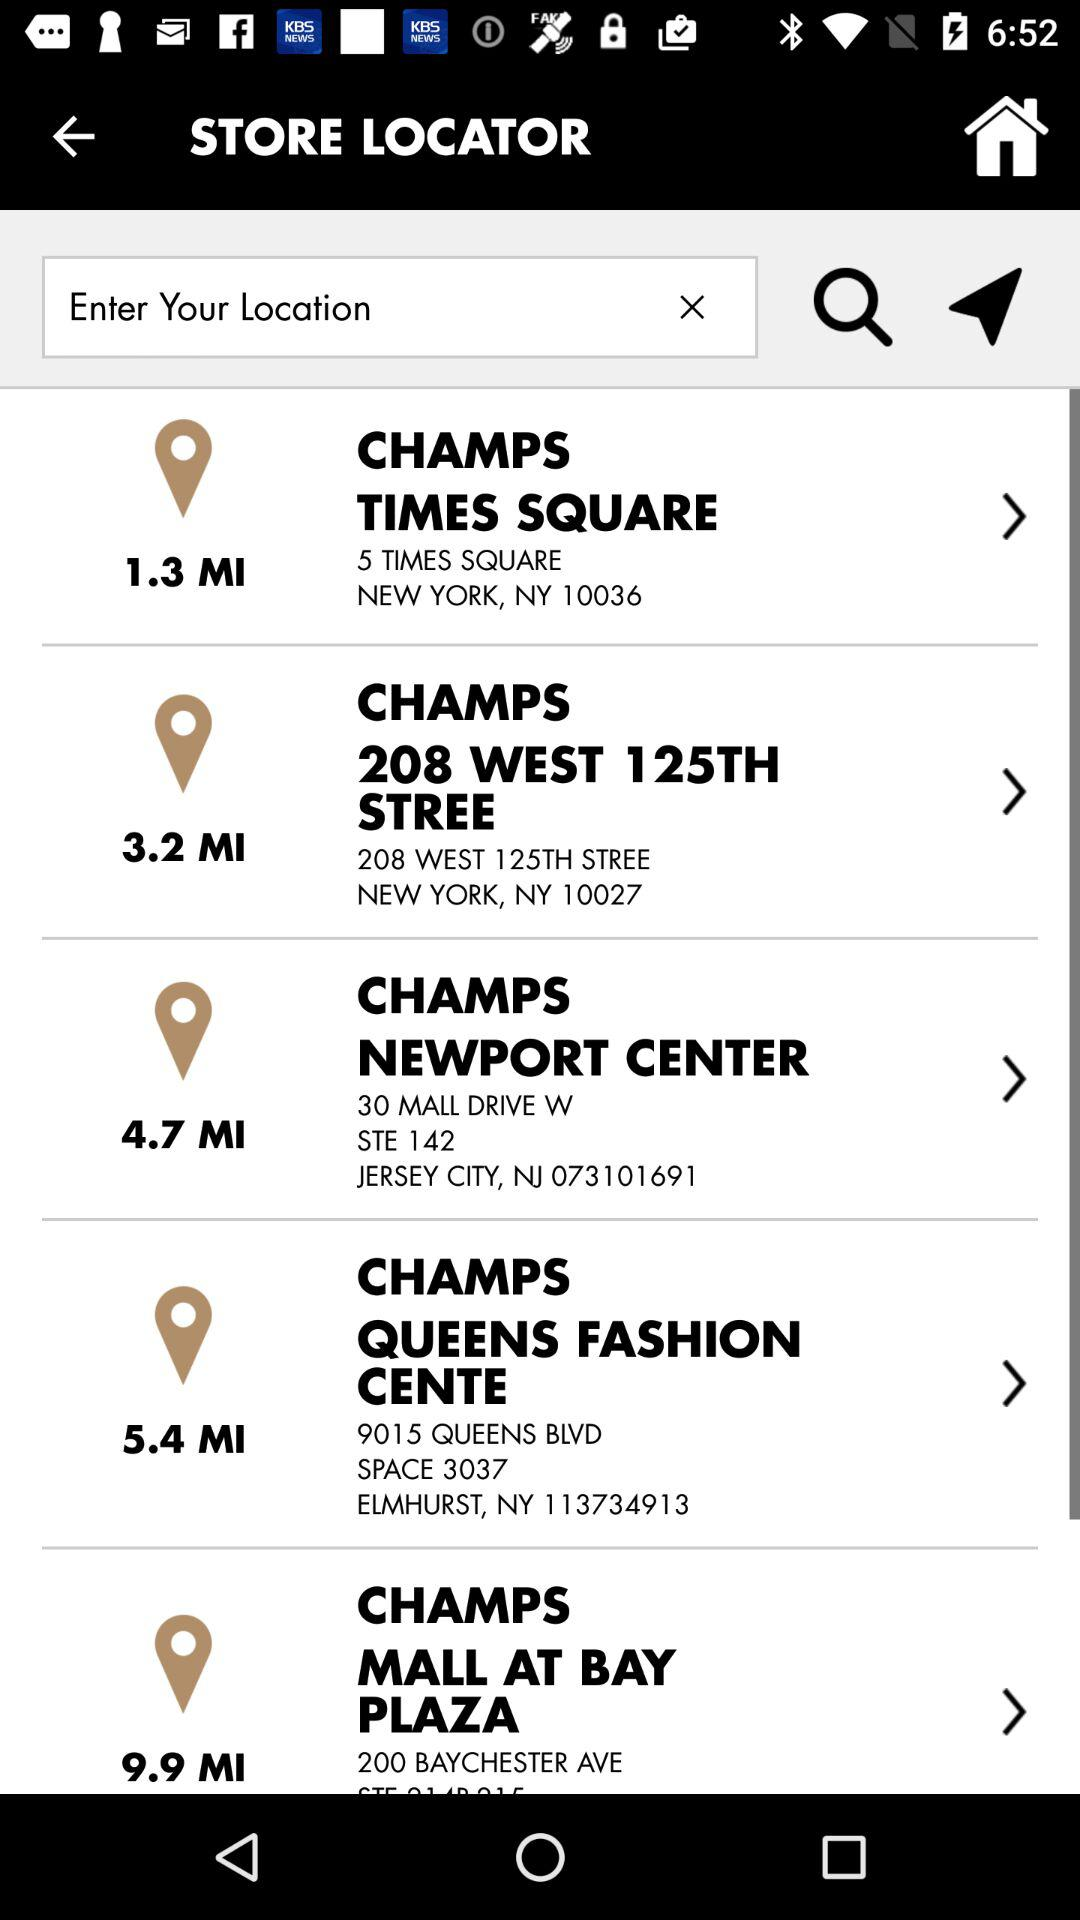In which city is the "CHAMPS TIME SQUARE" located? It is located in New York. 